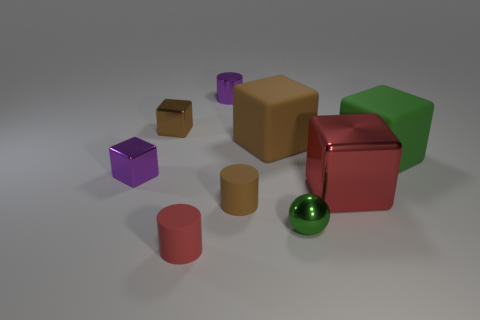Subtract all cyan cylinders. How many brown blocks are left? 2 Subtract 1 blocks. How many blocks are left? 4 Subtract all large red cubes. How many cubes are left? 4 Subtract all brown blocks. How many blocks are left? 3 Subtract all spheres. How many objects are left? 8 Subtract all gray cubes. Subtract all gray balls. How many cubes are left? 5 Add 8 large rubber cubes. How many large rubber cubes exist? 10 Subtract 1 brown blocks. How many objects are left? 8 Subtract all brown things. Subtract all tiny brown metallic cylinders. How many objects are left? 6 Add 5 big metal objects. How many big metal objects are left? 6 